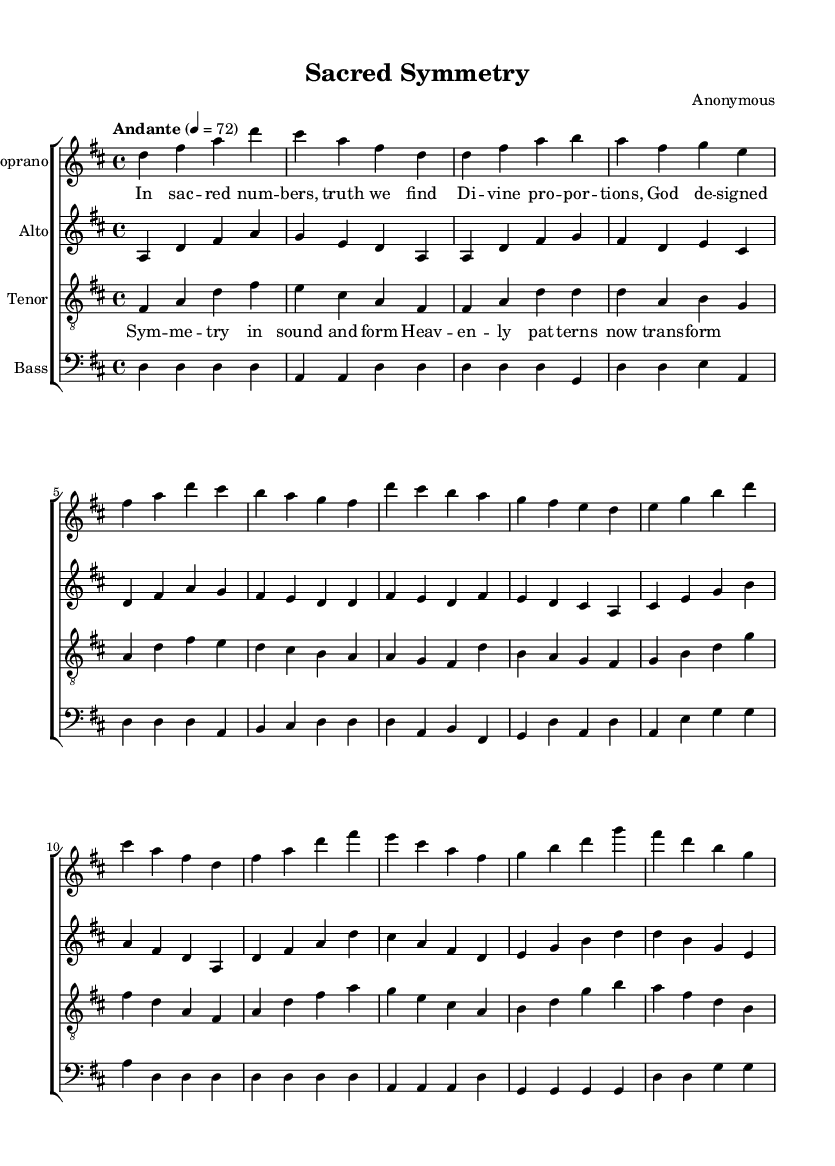What is the key signature of this music? The key signature is determined by the number of sharps or flats indicated at the beginning of the staff. In this case, it is D major, which has two sharps: F# and C#.
Answer: D major What is the time signature of this music? The time signature is found at the start of the piece, indicating how many beats are in each measure. Here, it shows 4/4, meaning there are four beats per measure.
Answer: 4/4 What is the tempo marking for this choral arrangement? The tempo is indicated above the staff, specifying the speed of the piece. In this score, it is marked as "Andante," with a tempo of 72 beats per minute.
Answer: Andante How many voices are present in this arrangement? The arrangement includes four distinct voices: Soprano, Alto, Tenor, and Bass. The presence of each voice is indicated by separate staves for each part.
Answer: Four What is the main thematic element expressed in the lyrics of the first verse? The first verse discusses the theme of divine proportions and the search for truth, suggesting a connection to religious or spiritual concepts through the imagery of "sacred numbers."
Answer: Divine proportions Which musical technique is evident in the arrangement's complexity? The arrangement showcases complex harmonies that are typical in traditional religious choral music, often based on mathematical patterns like counterpoint and symmetrical structures.
Answer: Complex harmonies Identify a unique feature of the tenor voice in this piece. The tenor voice has specific phrases that demonstrate a mixture of melodic lines that intertwine with the harmonies, often moving in a parallel motion with the alto and bass, creating a rich textural blend.
Answer: Intertwining melodic lines 